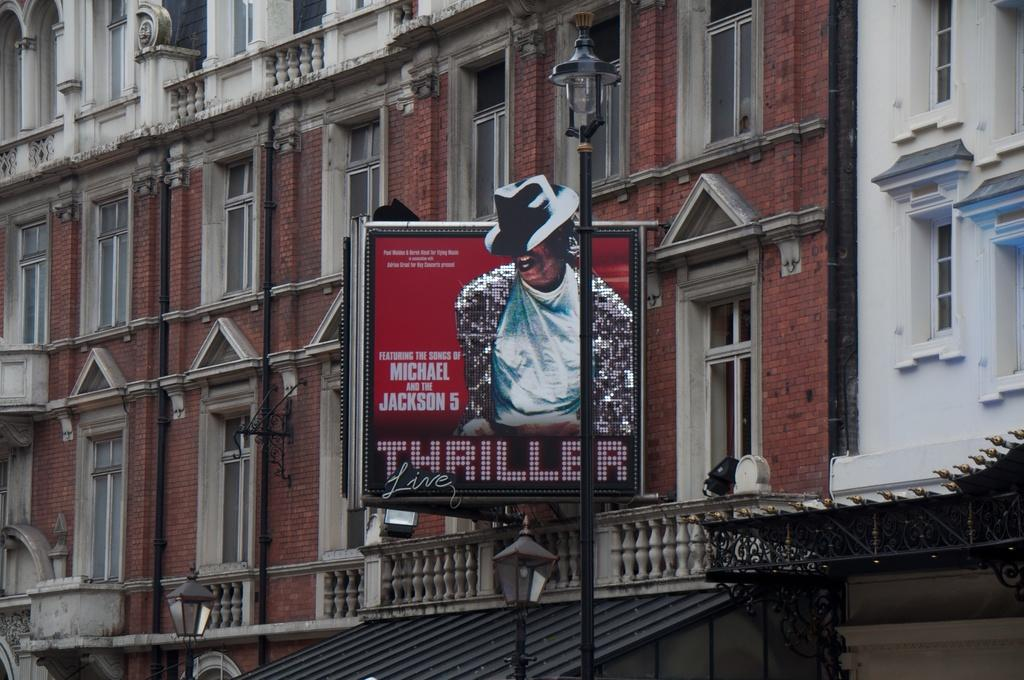What type of structure is present in the image? There is a building in the image. What object can be seen near the building? There is a board in the image. What can be seen illuminating the area in the image? There are lights visible in the image. What type of cord is used to connect the nation in the image? There is no mention of a nation or a cord in the image; it only features a building and a board with lights. 